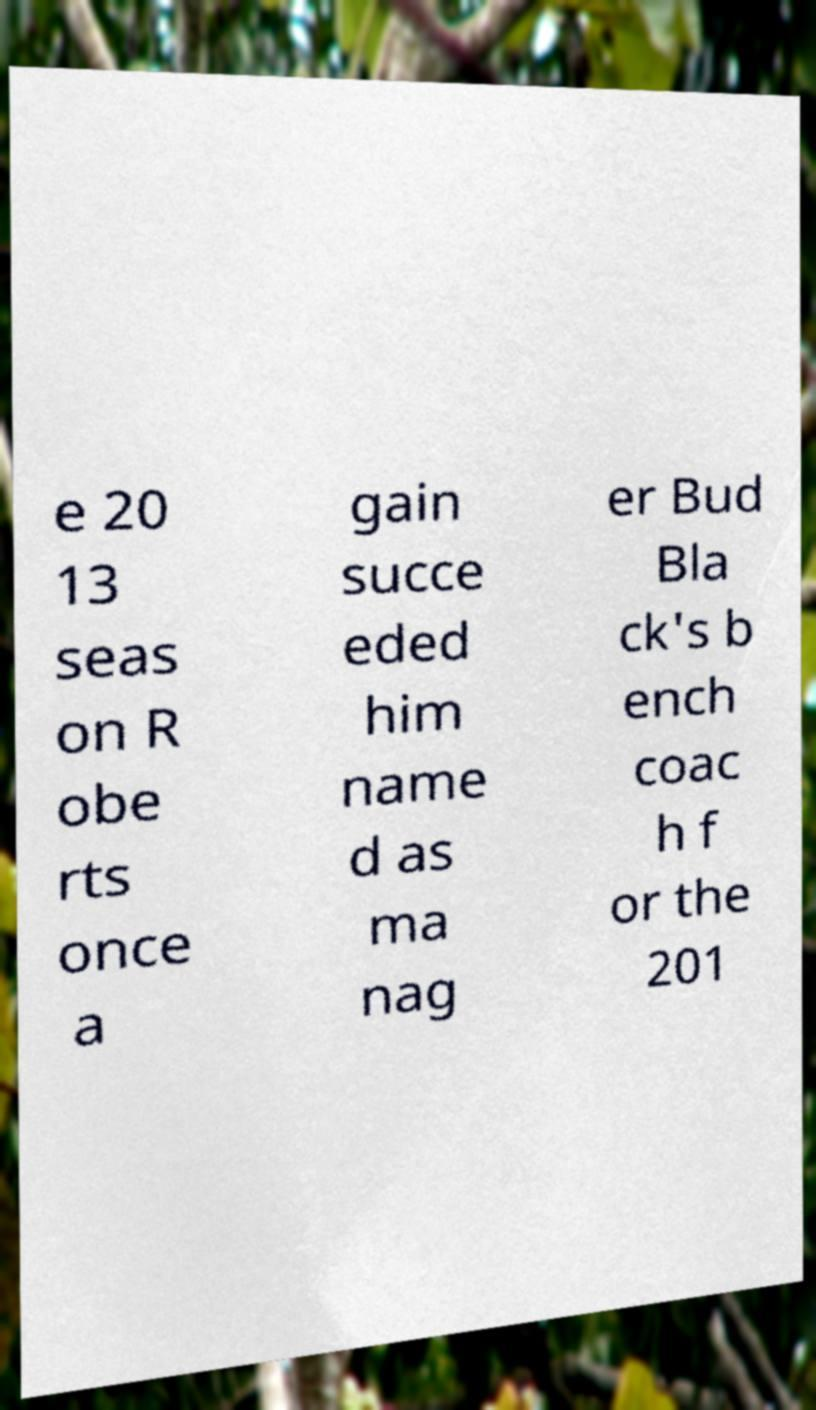Could you assist in decoding the text presented in this image and type it out clearly? e 20 13 seas on R obe rts once a gain succe eded him name d as ma nag er Bud Bla ck's b ench coac h f or the 201 